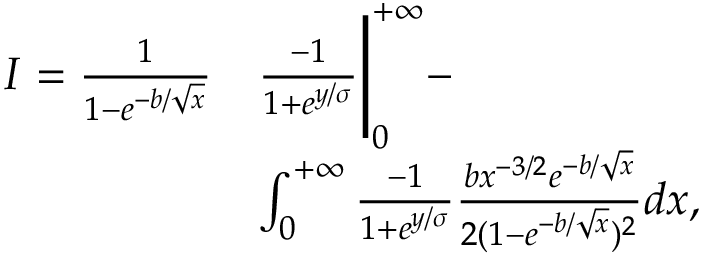Convert formula to latex. <formula><loc_0><loc_0><loc_500><loc_500>\begin{array} { r l } { I = \frac { 1 } { 1 - e ^ { - b / \sqrt { x } } } } & { \frac { - 1 } { 1 + e ^ { y / \sigma } } \Big | _ { 0 } ^ { + \infty } - } \\ & { \int _ { 0 } ^ { + \infty } \frac { - 1 } { 1 + e ^ { y / \sigma } } \frac { b x ^ { - 3 / 2 } e ^ { - b / \sqrt { x } } } { 2 ( 1 - e ^ { - b / \sqrt { x } } ) ^ { 2 } } d x , } \end{array}</formula> 